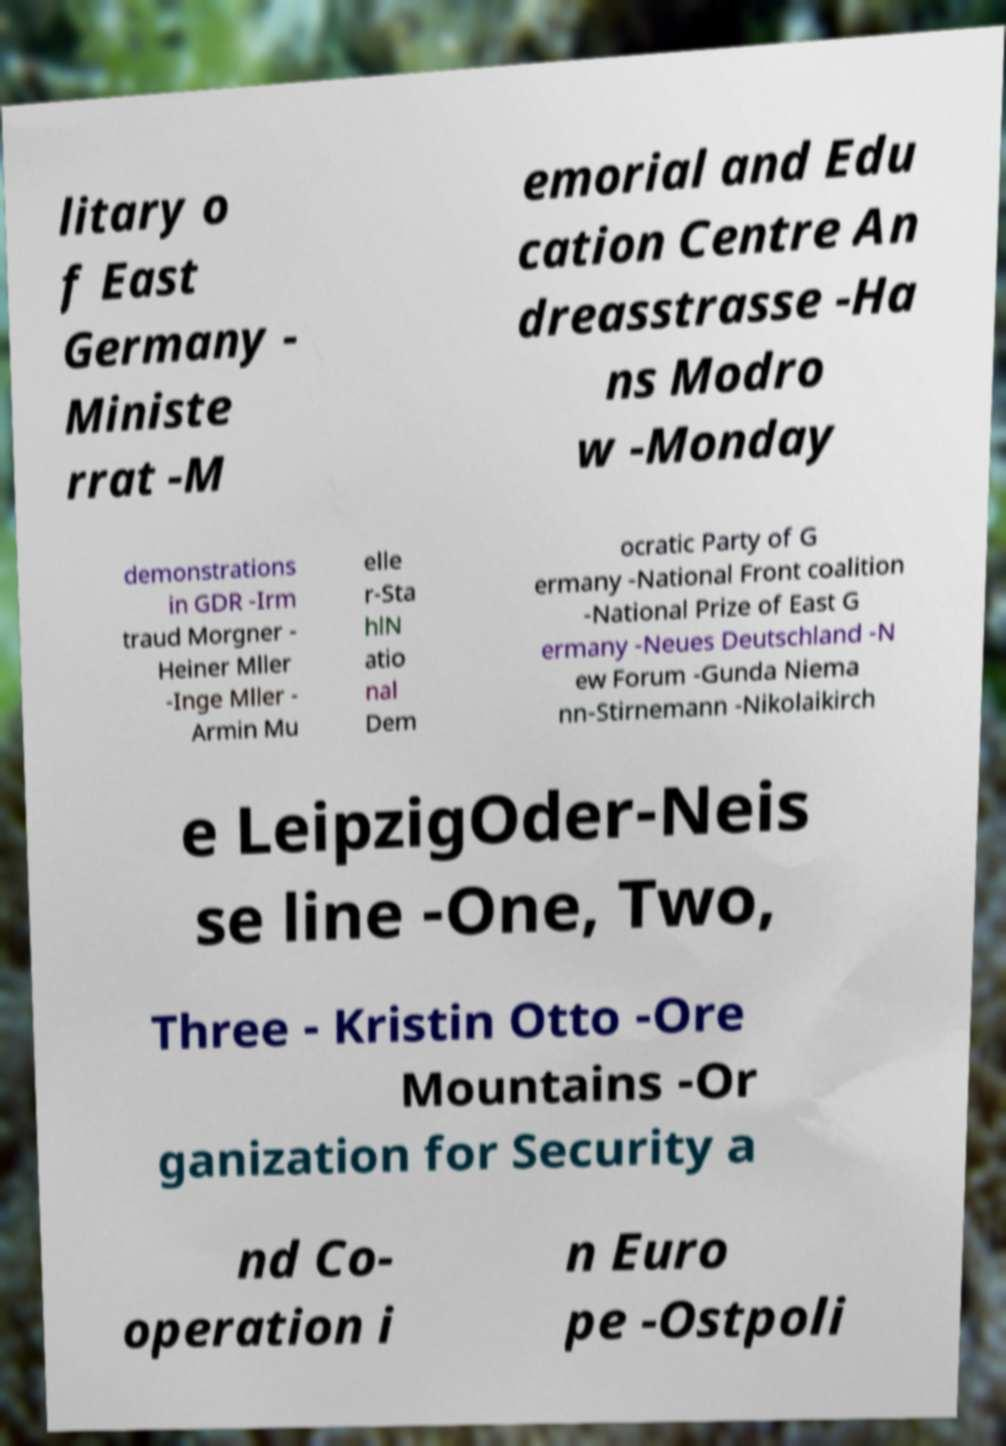There's text embedded in this image that I need extracted. Can you transcribe it verbatim? litary o f East Germany - Ministe rrat -M emorial and Edu cation Centre An dreasstrasse -Ha ns Modro w -Monday demonstrations in GDR -Irm traud Morgner - Heiner Mller -Inge Mller - Armin Mu elle r-Sta hlN atio nal Dem ocratic Party of G ermany -National Front coalition -National Prize of East G ermany -Neues Deutschland -N ew Forum -Gunda Niema nn-Stirnemann -Nikolaikirch e LeipzigOder-Neis se line -One, Two, Three - Kristin Otto -Ore Mountains -Or ganization for Security a nd Co- operation i n Euro pe -Ostpoli 